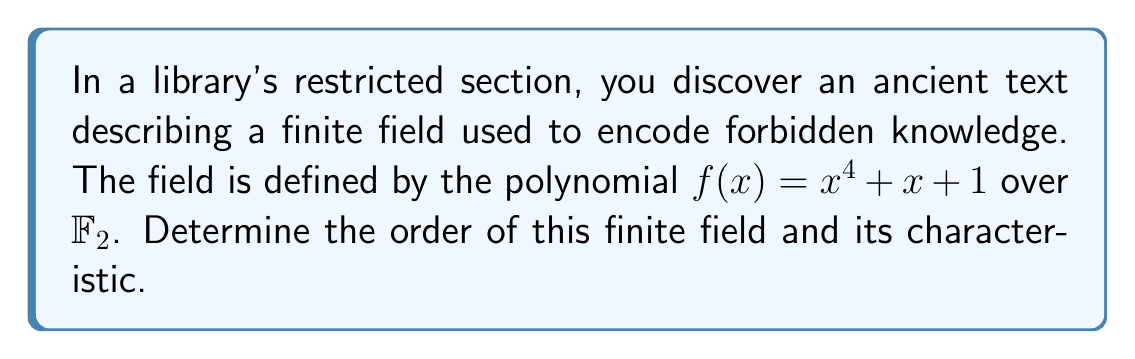Show me your answer to this math problem. To solve this problem, we'll follow these steps:

1) The order of a finite field is always a power of a prime number. In this case, we're working over $\mathbb{F}_2$, so the characteristic is 2.

2) The degree of the polynomial $f(x) = x^4 + x + 1$ is 4. This means that the field we're dealing with is an extension of $\mathbb{F}_2$ of degree 4.

3) The order of a finite field extension is given by $p^n$, where $p$ is the characteristic of the base field and $n$ is the degree of the extension.

4) In this case:
   $p = 2$ (characteristic of $\mathbb{F}_2$)
   $n = 4$ (degree of the polynomial)

5) Therefore, the order of the field is:

   $$2^4 = 16$$

6) The characteristic of a finite field is always equal to the characteristic of its base field. Since we're working over $\mathbb{F}_2$, the characteristic is 2.
Answer: Order: 16, Characteristic: 2 